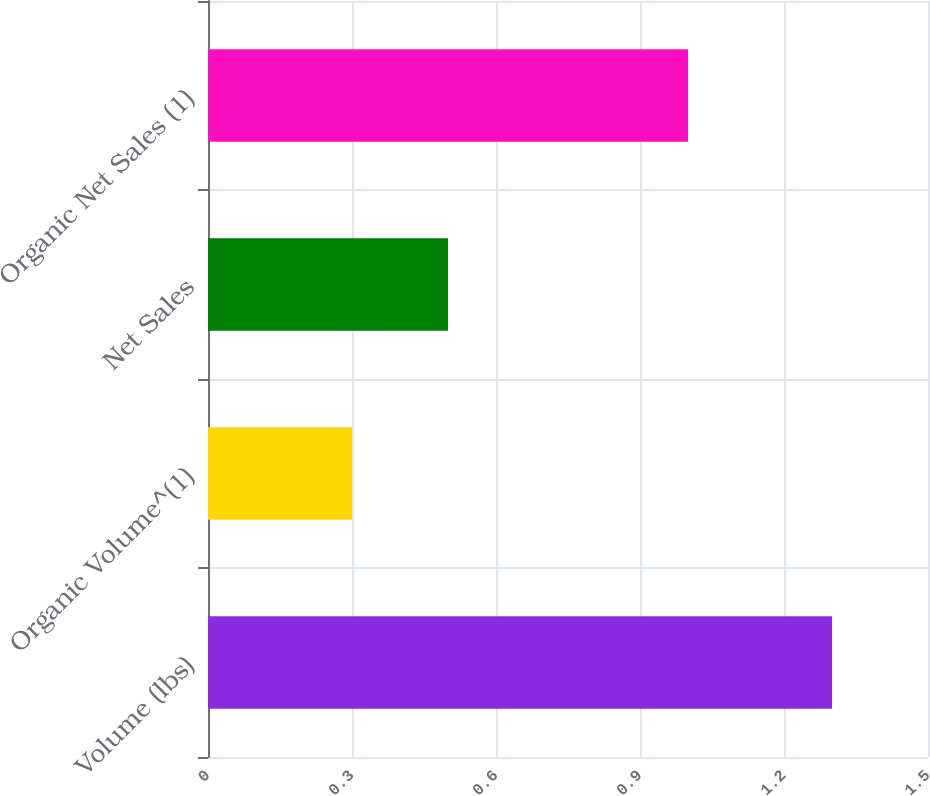<chart> <loc_0><loc_0><loc_500><loc_500><bar_chart><fcel>Volume (lbs)<fcel>Organic Volume^(1)<fcel>Net Sales<fcel>Organic Net Sales (1)<nl><fcel>1.3<fcel>0.3<fcel>0.5<fcel>1<nl></chart> 